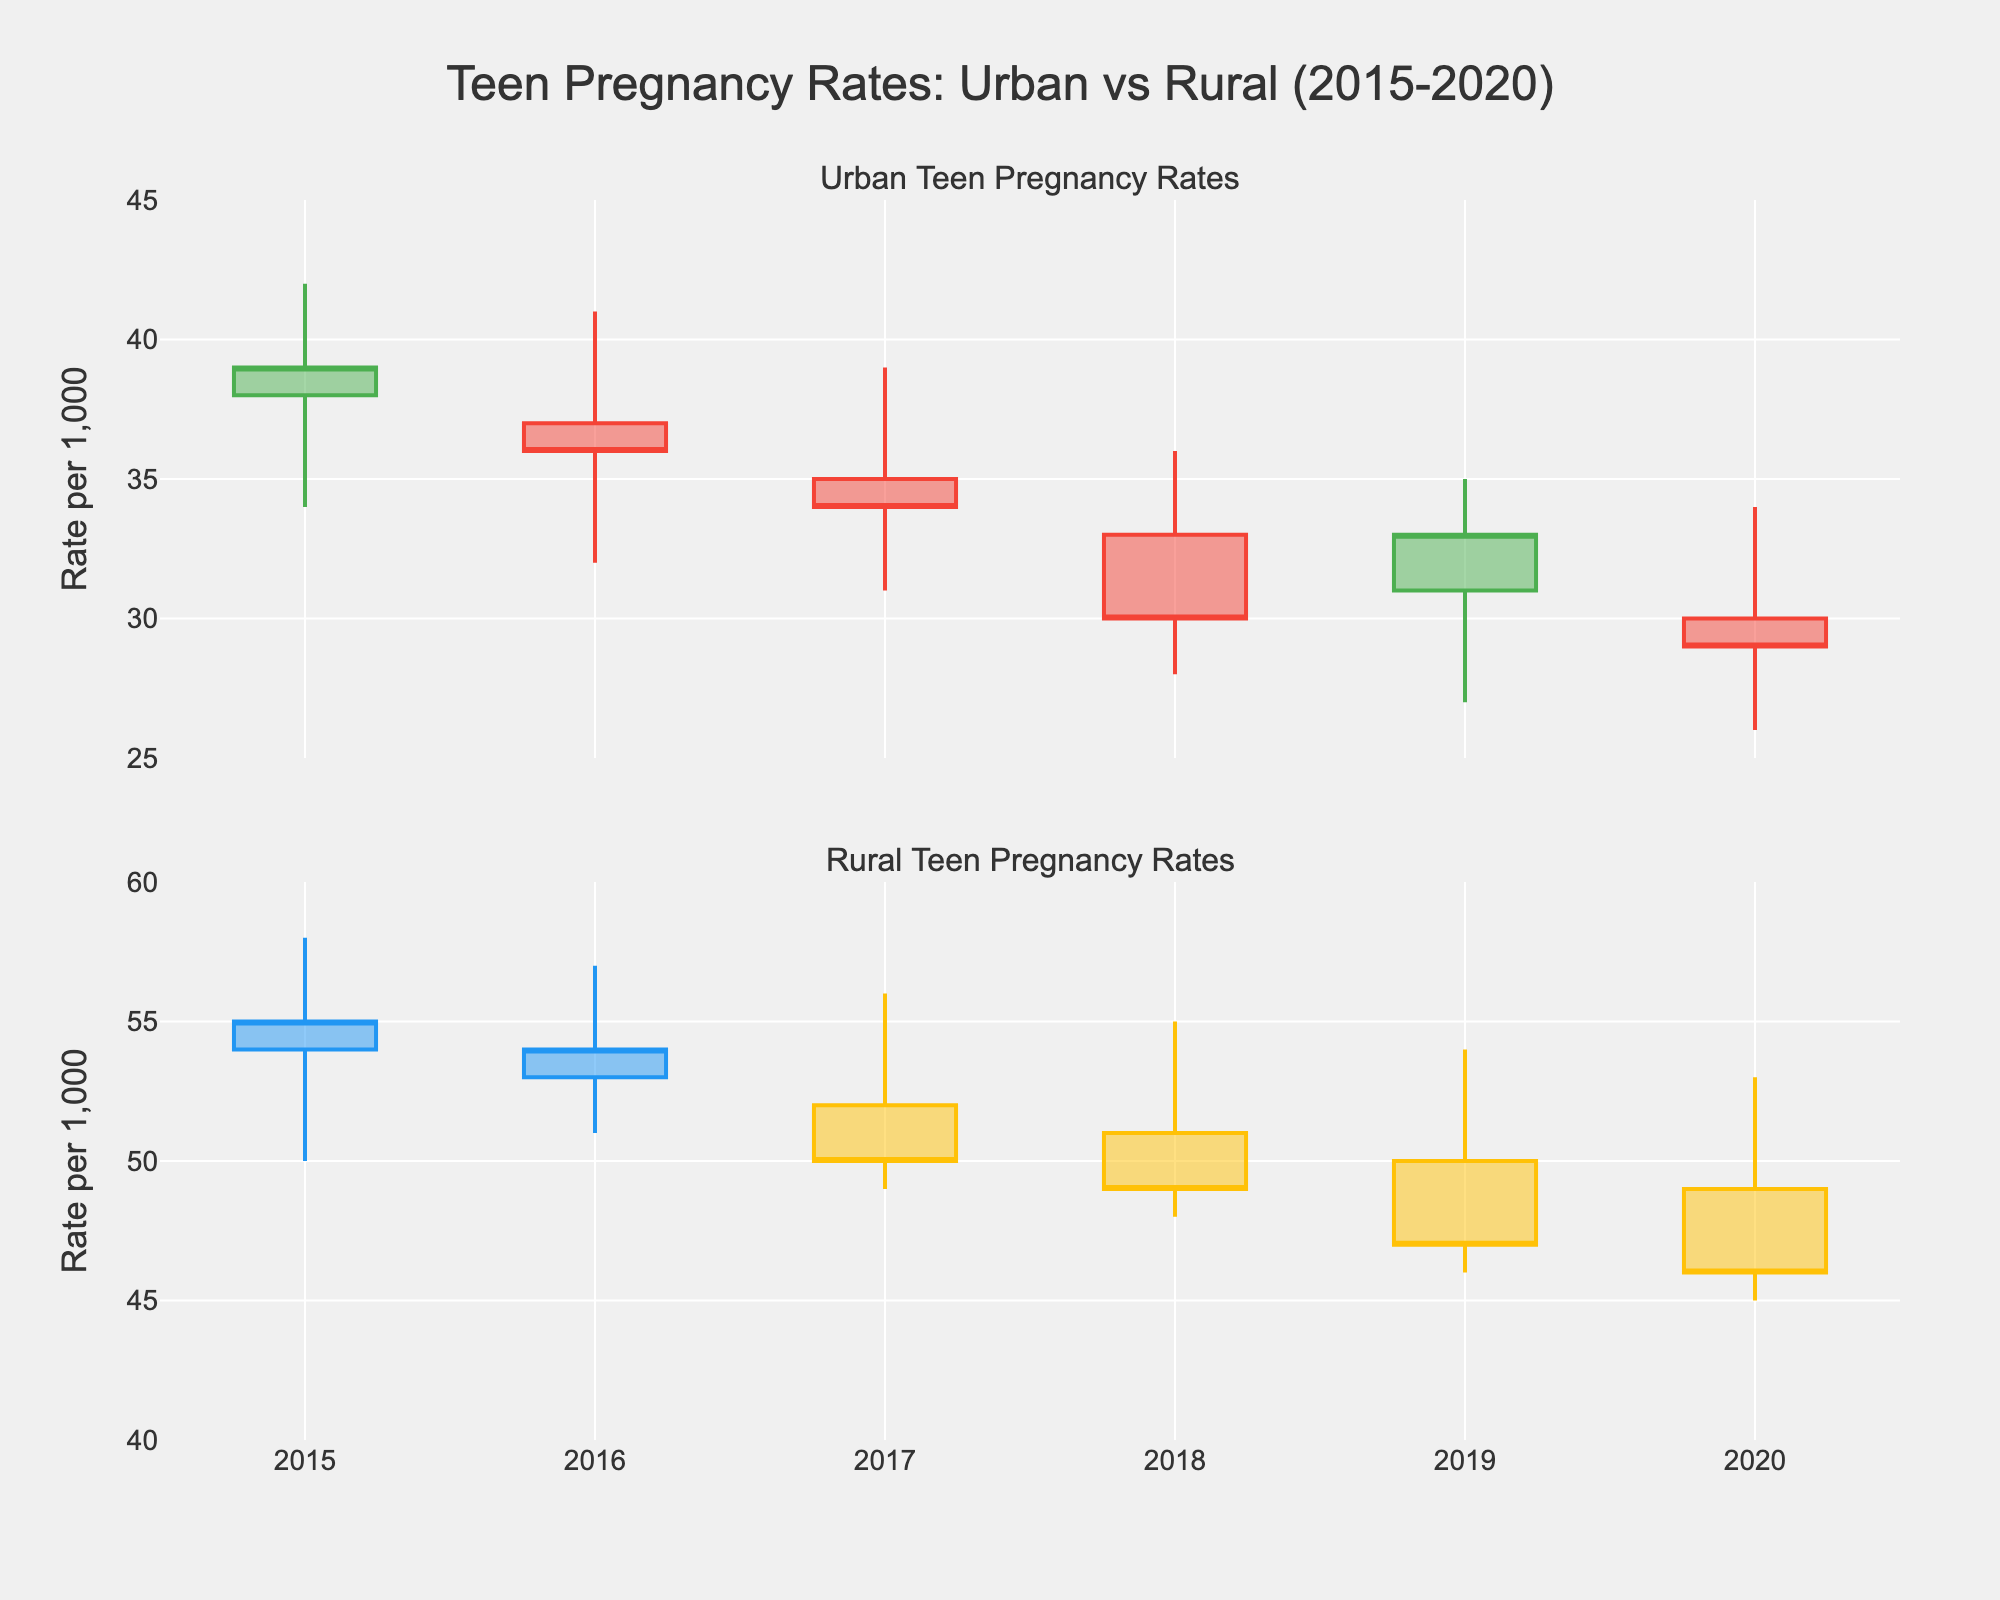What is the title of the figure? The title of the figure is prominently displayed at the top.
Answer: Teen Pregnancy Rates: Urban vs Rural (2015-2020) What do the colors green and red represent in the urban plot? In candlestick charts, green typically indicates an increase (when the close value is higher than the open value) and red indicates a decrease (when the close value is lower than the open value).
Answer: Increase and decrease How many years of data are represented in the plot? Analyzing the x-axis labels, the data spans from 2015 to 2020.
Answer: 6 years Which region shows a higher range of teen pregnancy rates throughout the given years? By comparing the ranges of high and low values in both urban and rural plots, it's clear that the rural region has consistently higher values.
Answer: Rural What was the highest teen pregnancy rate recorded in urban areas? In the urban plot, the highest value is indicated by the topmost "high" wick.
Answer: 42 In which year did the rural area experience the lowest teen pregnancy rate? Reviewing the rural plot, the lowest rate is indicated by the bottommost "low" wick in 2020.
Answer: 45 What is the average closing rate for urban areas over the span of the data? Sum the close values for urban areas (39+36+34+30+33+29) and then divide by the number of years. (39+36+34+30+33+29)/6 = 201/6.
Answer: 33.5 Which year showed the highest opening rate in rural areas? Check the "open" values for each year in the rural plot. The highest opening rate is in 2015, at 54.
Answer: 2015 Did the teen pregnancy rates in urban areas generally increase or decrease from 2015 to 2020? Observing the overall trend in the urban plot: 38 (2015) to 30 (2020), the rates show a decreasing trend.
Answer: Decrease By how much did the rural teen pregnancy rate decrease from its highest recorded close to its lowest recorded close? The highest close for rural is 55 (2015), and the lowest close is 46 (2020). The difference is 55 - 46 = 9.
Answer: 9 